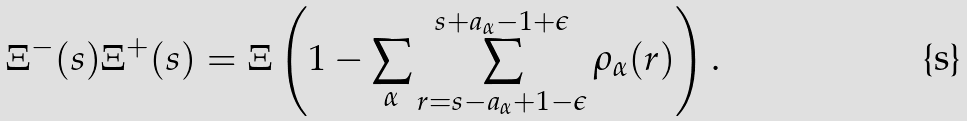Convert formula to latex. <formula><loc_0><loc_0><loc_500><loc_500>\Xi ^ { - } ( s ) \Xi ^ { + } ( s ) = \Xi \left ( 1 - \sum _ { \alpha } \sum _ { r = s - a _ { \alpha } + 1 - \epsilon } ^ { s + a _ { \alpha } - 1 + \epsilon } \rho _ { \alpha } ( r ) \right ) .</formula> 